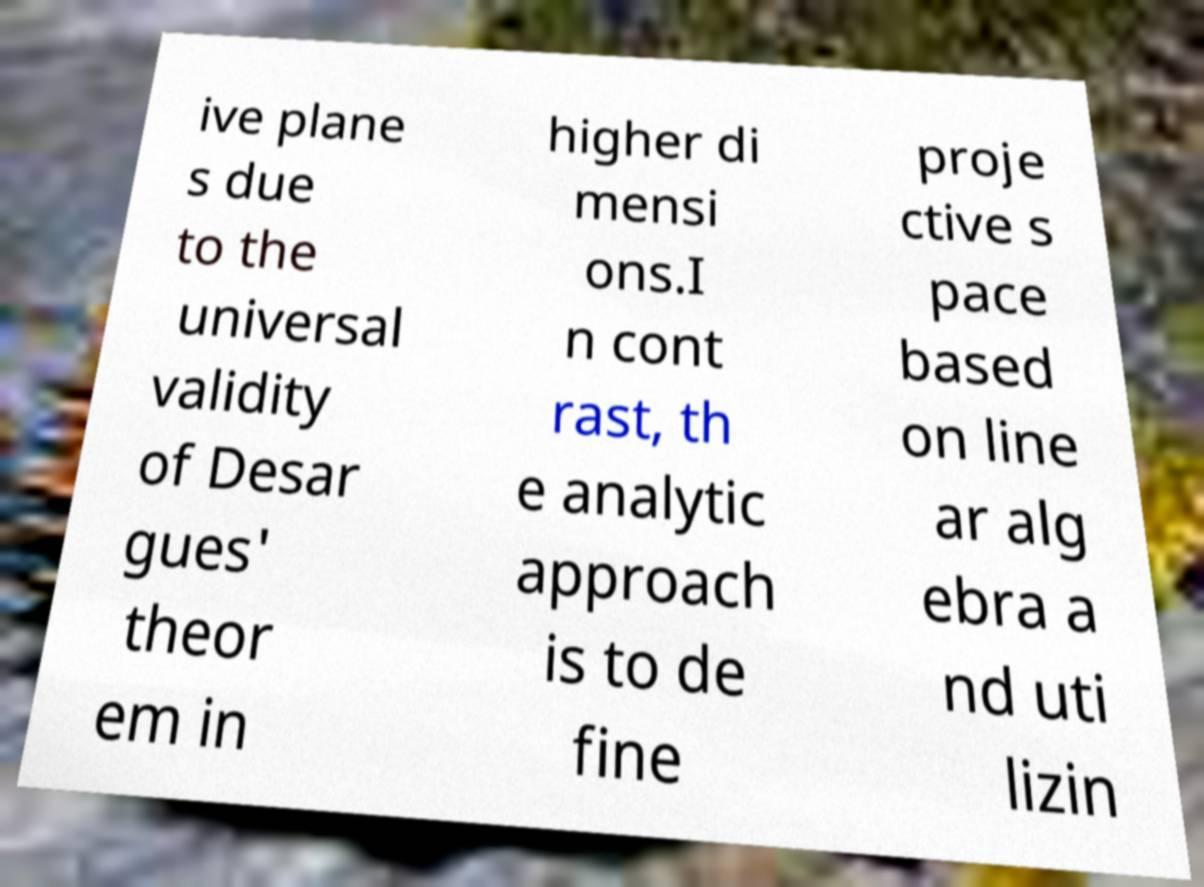Please read and relay the text visible in this image. What does it say? ive plane s due to the universal validity of Desar gues' theor em in higher di mensi ons.I n cont rast, th e analytic approach is to de fine proje ctive s pace based on line ar alg ebra a nd uti lizin 